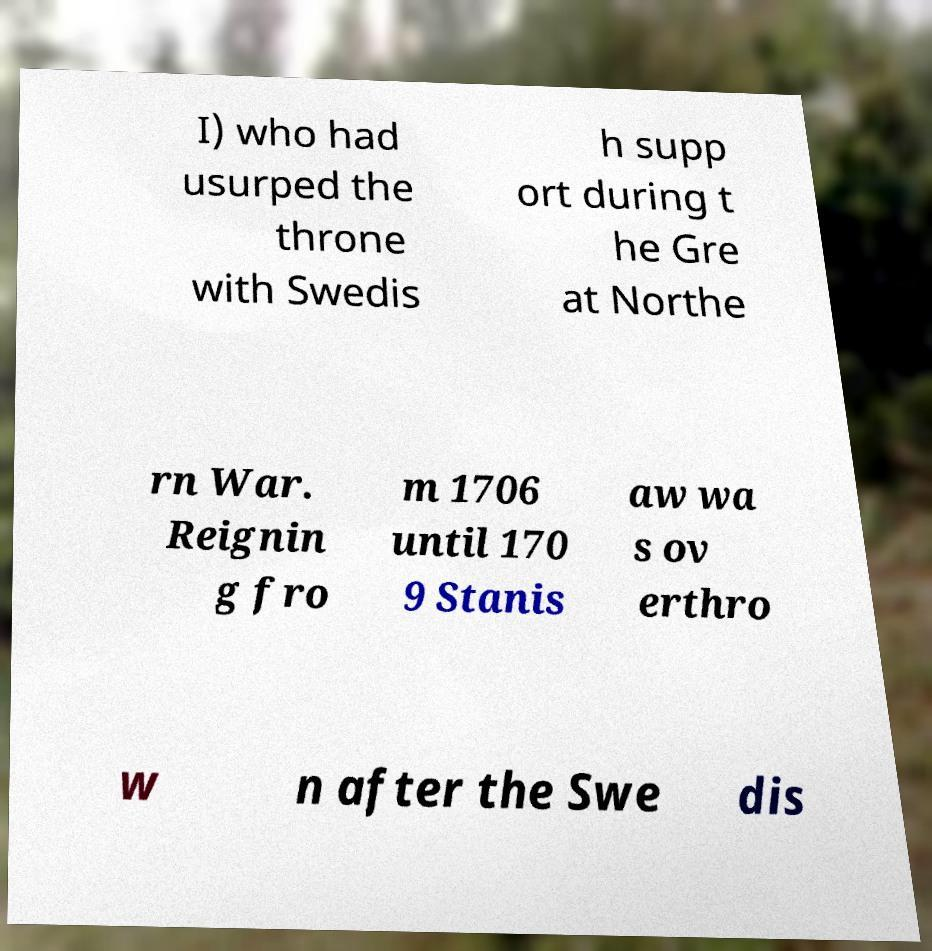What messages or text are displayed in this image? I need them in a readable, typed format. I) who had usurped the throne with Swedis h supp ort during t he Gre at Northe rn War. Reignin g fro m 1706 until 170 9 Stanis aw wa s ov erthro w n after the Swe dis 